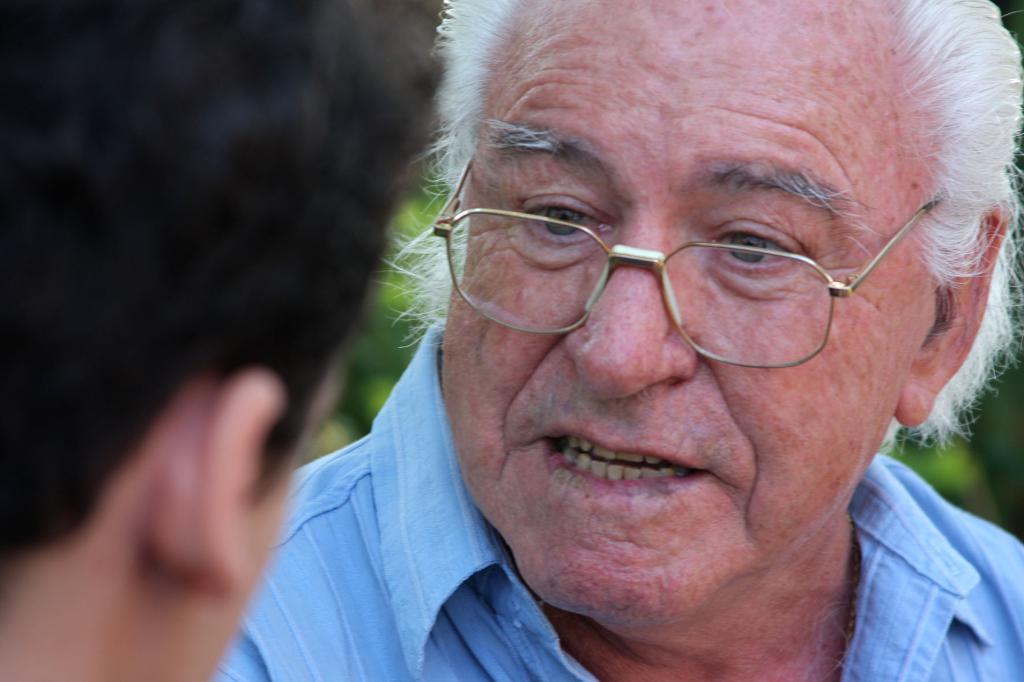Please provide a concise description of this image. This person wore spectacles and looking at the opposite person. Background it is blur. 